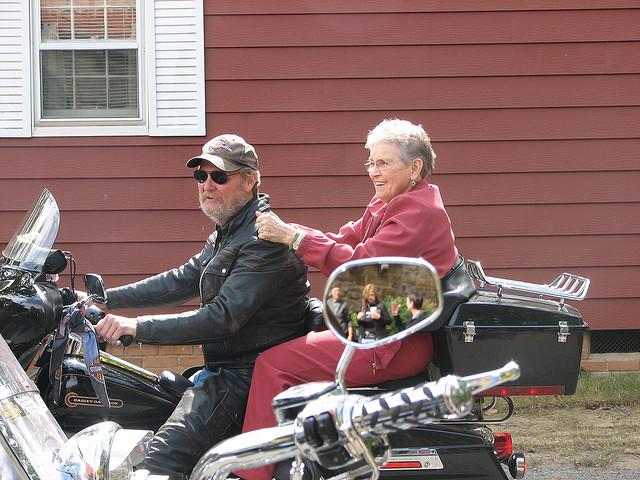Would you say the riders are over 50 years of age?
Keep it brief. Yes. What color is her jumpsuit?
Give a very brief answer. Red. What is in the mirror?
Keep it brief. People. 